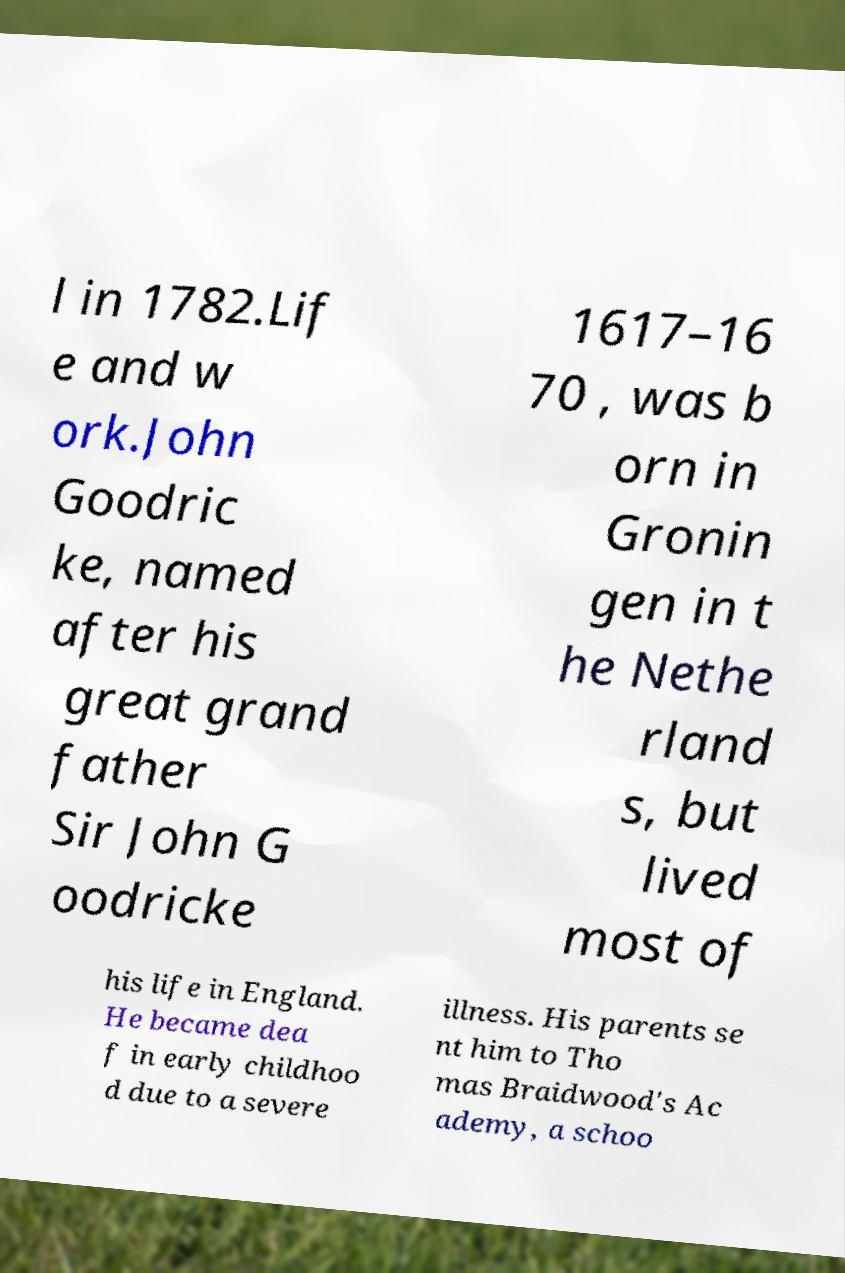Please read and relay the text visible in this image. What does it say? l in 1782.Lif e and w ork.John Goodric ke, named after his great grand father Sir John G oodricke 1617–16 70 , was b orn in Gronin gen in t he Nethe rland s, but lived most of his life in England. He became dea f in early childhoo d due to a severe illness. His parents se nt him to Tho mas Braidwood's Ac ademy, a schoo 